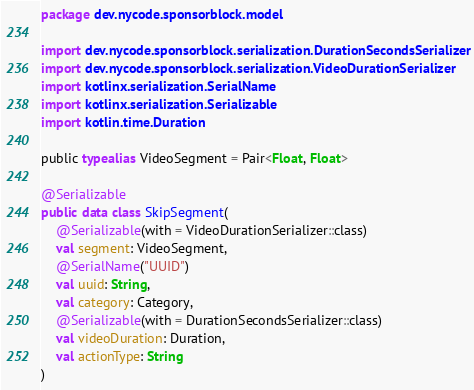<code> <loc_0><loc_0><loc_500><loc_500><_Kotlin_>package dev.nycode.sponsorblock.model

import dev.nycode.sponsorblock.serialization.DurationSecondsSerializer
import dev.nycode.sponsorblock.serialization.VideoDurationSerializer
import kotlinx.serialization.SerialName
import kotlinx.serialization.Serializable
import kotlin.time.Duration

public typealias VideoSegment = Pair<Float, Float>

@Serializable
public data class SkipSegment(
    @Serializable(with = VideoDurationSerializer::class)
    val segment: VideoSegment,
    @SerialName("UUID")
    val uuid: String,
    val category: Category,
    @Serializable(with = DurationSecondsSerializer::class)
    val videoDuration: Duration,
    val actionType: String
)
</code> 